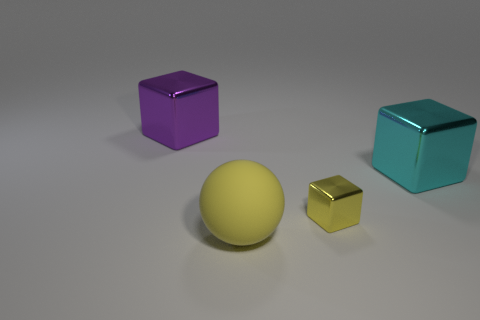The big thing that is in front of the big shiny cube that is on the right side of the object that is behind the cyan metallic cube is what shape?
Make the answer very short. Sphere. What number of other objects are the same shape as the small yellow object?
Make the answer very short. 2. What is the color of the matte sphere that is the same size as the cyan metal block?
Your answer should be very brief. Yellow. What number of cubes are either metal things or large purple metallic objects?
Offer a terse response. 3. What number of small cyan matte cylinders are there?
Your answer should be very brief. 0. Is the shape of the big cyan thing the same as the big metallic object that is on the left side of the large cyan shiny object?
Keep it short and to the point. Yes. There is a block that is the same color as the ball; what is its size?
Offer a terse response. Small. How many things are large yellow things or big cyan objects?
Your answer should be very brief. 2. There is a big thing that is in front of the metal object to the right of the small yellow thing; what is its shape?
Ensure brevity in your answer.  Sphere. There is a object behind the big cyan object; is it the same shape as the tiny shiny object?
Offer a terse response. Yes. 